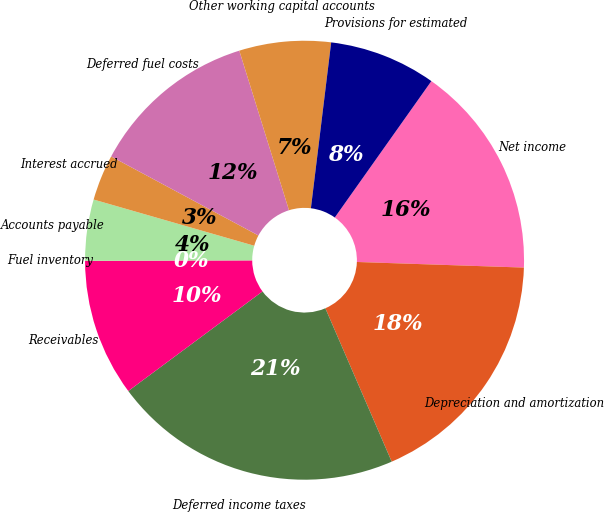Convert chart. <chart><loc_0><loc_0><loc_500><loc_500><pie_chart><fcel>Net income<fcel>Depreciation and amortization<fcel>Deferred income taxes<fcel>Receivables<fcel>Fuel inventory<fcel>Accounts payable<fcel>Interest accrued<fcel>Deferred fuel costs<fcel>Other working capital accounts<fcel>Provisions for estimated<nl><fcel>15.73%<fcel>17.97%<fcel>21.34%<fcel>10.11%<fcel>0.01%<fcel>4.5%<fcel>3.38%<fcel>12.36%<fcel>6.74%<fcel>7.87%<nl></chart> 